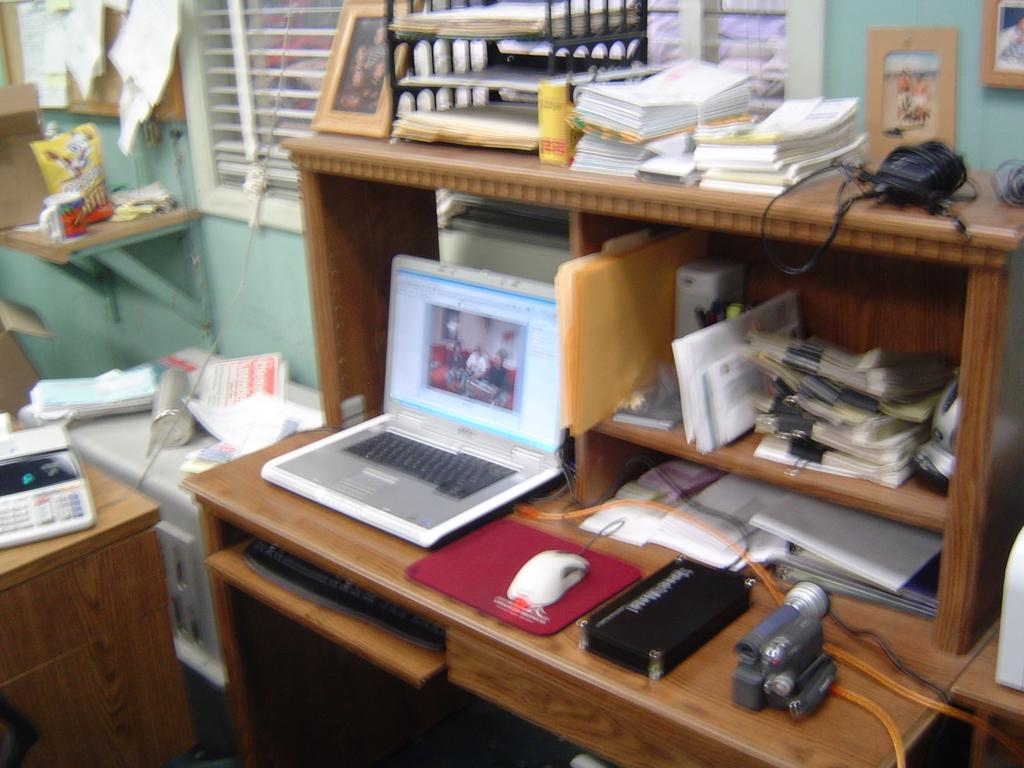What type of furniture is present in the image? There is a table and a desk in the image. What electronic device can be seen in the image? There is a laptop in the image. What accessories are used with the laptop? There is a keyboard, a mouse, and a mouse pad in the image. What other objects are present in the image? There is a camera, papers, and books in the image. What is visible outside the window in the image? The presence of a window suggests that there might be a view outside, but the specifics are not mentioned in the facts. What type of straw is used to drink from the laptop in the image? There is no straw or liquid present in the image, as the laptop is an electronic device and not a container for beverages. 